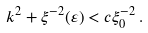<formula> <loc_0><loc_0><loc_500><loc_500>k ^ { 2 } + \xi ^ { - 2 } ( \varepsilon ) < c \xi _ { 0 } ^ { - 2 } \, .</formula> 